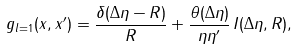<formula> <loc_0><loc_0><loc_500><loc_500>g _ { l = 1 } ( x , x ^ { \prime } ) = \frac { \delta ( \Delta \eta - R ) } { R } + \frac { \theta ( \Delta \eta ) } { \eta \eta ^ { \prime } } \, I ( \Delta \eta , R ) ,</formula> 